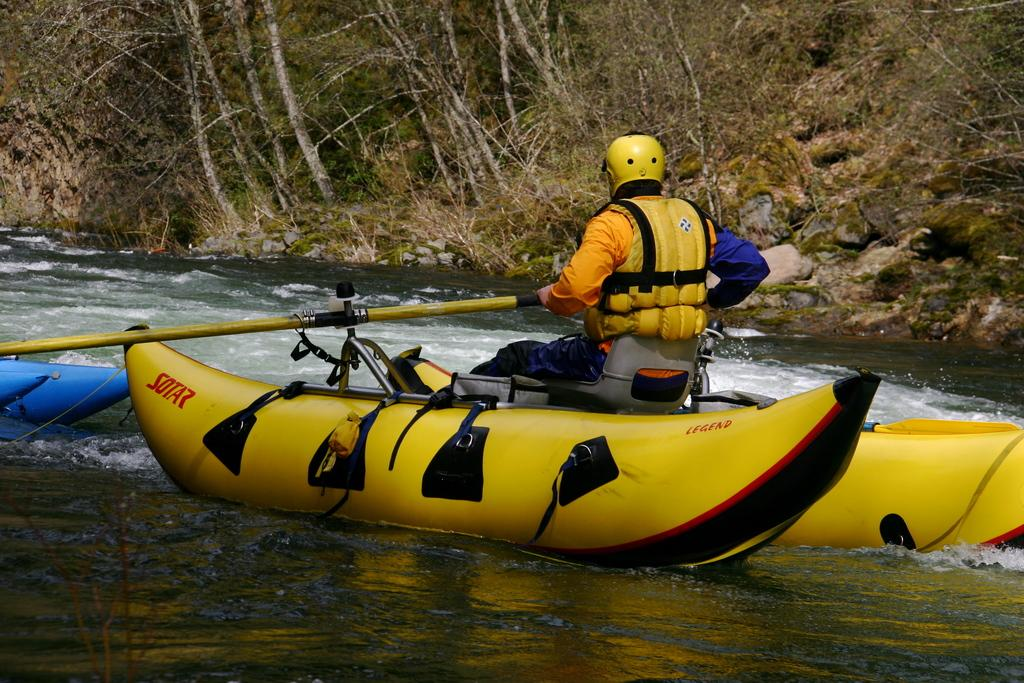Provide a one-sentence caption for the provided image. A man in a Sotar river raft is wearing a yellow helmet. 